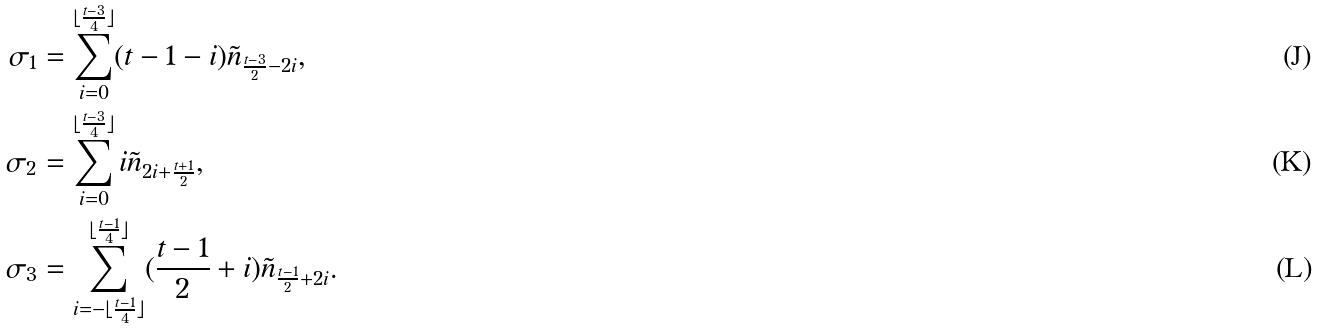Convert formula to latex. <formula><loc_0><loc_0><loc_500><loc_500>\sigma _ { 1 } & = \sum _ { i = 0 } ^ { \lfloor \frac { t - 3 } { 4 } \rfloor } ( t - 1 - i ) \tilde { n } _ { \frac { t - 3 } { 2 } - 2 i } , \\ \sigma _ { 2 } & = \sum _ { i = 0 } ^ { \lfloor \frac { t - 3 } { 4 } \rfloor } i \tilde { n } _ { 2 i + \frac { t + 1 } { 2 } } , \\ \sigma _ { 3 } & = \sum _ { i = - \lfloor \frac { t - 1 } { 4 } \rfloor } ^ { \lfloor \frac { t - 1 } { 4 } \rfloor } ( \frac { t - 1 } { 2 } + i ) \tilde { n } _ { \frac { t - 1 } { 2 } + 2 i } .</formula> 